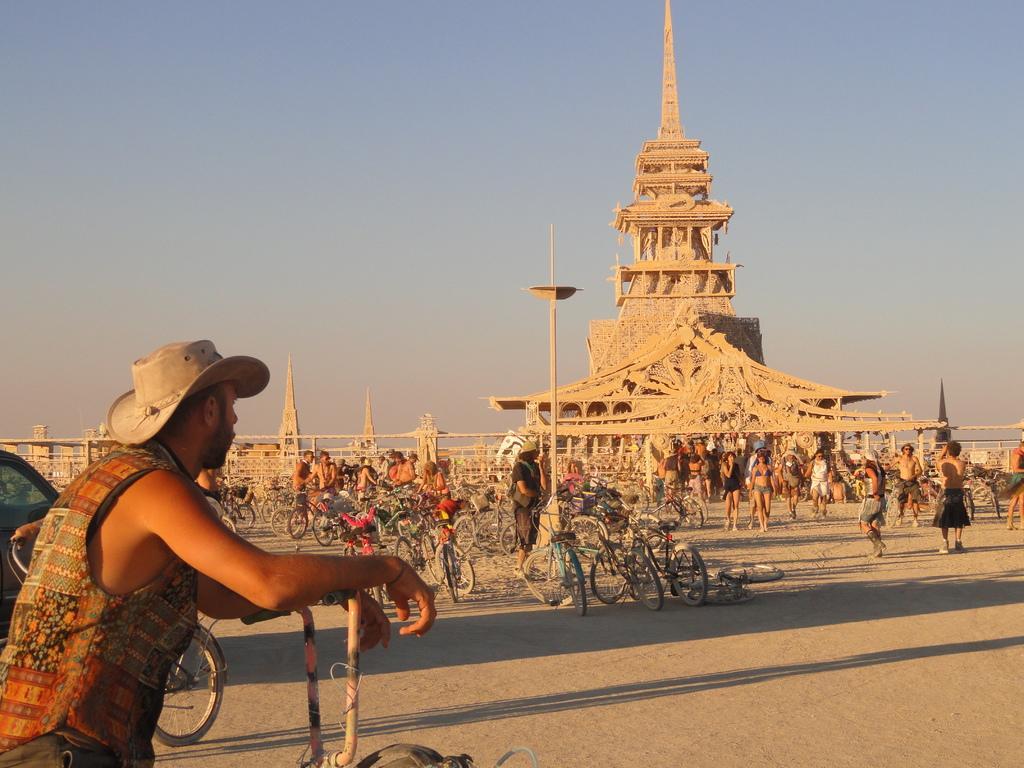Describe this image in one or two sentences. In the foreground of the image there is a person wearing a hat. In the center of the image there are bicycles, people walking on the road. In the background of the image there is a concrete structure and sky. 